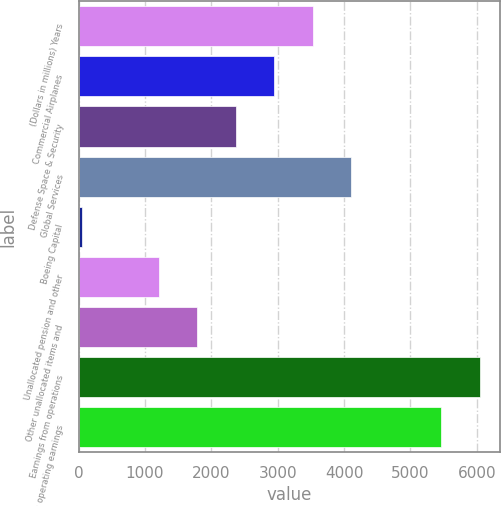<chart> <loc_0><loc_0><loc_500><loc_500><bar_chart><fcel>(Dollars in millions) Years<fcel>Commercial Airplanes<fcel>Defense Space & Security<fcel>Global Services<fcel>Boeing Capital<fcel>Unallocated pension and other<fcel>Other unallocated items and<fcel>Earnings from operations<fcel>Core operating earnings<nl><fcel>3524<fcel>2946.5<fcel>2369<fcel>4101.5<fcel>59<fcel>1214<fcel>1791.5<fcel>6041.5<fcel>5464<nl></chart> 